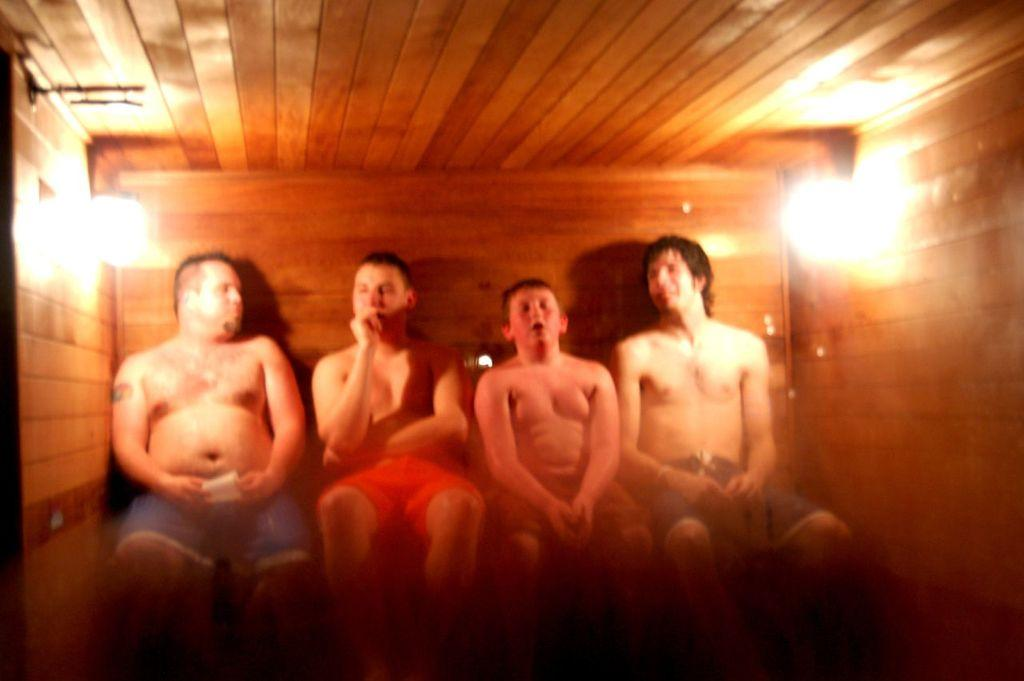How many people are in the image? There are four persons in the image. What are the persons doing in the image? The persons are sitting on a bench. What are the persons wearing in the image? The persons are wearing shorts in different colors. What is the material of the walls in the room? The walls of the room are made of wood. How many lights are present in the room? There are two lights arranged on the walls of the room. What type of soup is being served to the visitor in the image? There is no visitor or soup present in the image; it features four persons sitting on a bench. 